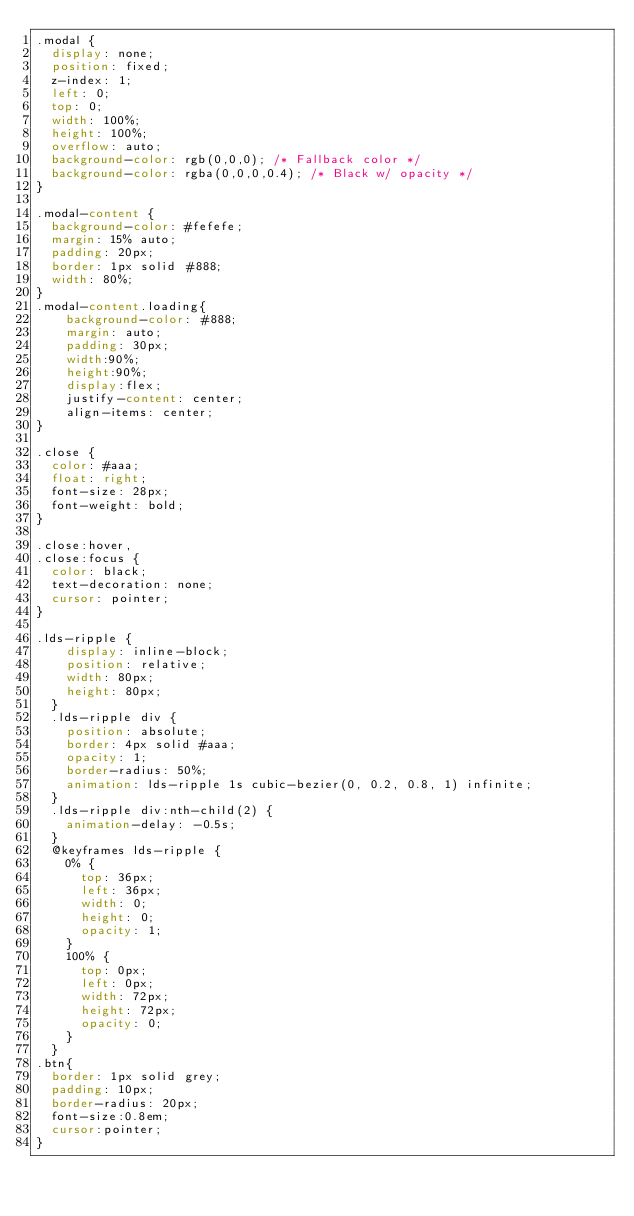<code> <loc_0><loc_0><loc_500><loc_500><_CSS_>.modal {
  display: none;
  position: fixed;
  z-index: 1;
  left: 0;
  top: 0;
  width: 100%; 
  height: 100%;
  overflow: auto;
  background-color: rgb(0,0,0); /* Fallback color */
  background-color: rgba(0,0,0,0.4); /* Black w/ opacity */
}

.modal-content {
  background-color: #fefefe;
  margin: 15% auto;
  padding: 20px;
  border: 1px solid #888;
  width: 80%;
}
.modal-content.loading{
    background-color: #888;
    margin: auto;
    padding: 30px;
    width:90%;
    height:90%;
    display:flex;
    justify-content: center;
    align-items: center;
}

.close {
  color: #aaa;
  float: right;
  font-size: 28px;
  font-weight: bold;
}

.close:hover,
.close:focus {
  color: black;
  text-decoration: none;
  cursor: pointer;
}

.lds-ripple {
    display: inline-block;
    position: relative;
    width: 80px;
    height: 80px;
  }
  .lds-ripple div {
    position: absolute;
    border: 4px solid #aaa;
    opacity: 1;
    border-radius: 50%;
    animation: lds-ripple 1s cubic-bezier(0, 0.2, 0.8, 1) infinite;
  }
  .lds-ripple div:nth-child(2) {
    animation-delay: -0.5s;
  }
  @keyframes lds-ripple {
    0% {
      top: 36px;
      left: 36px;
      width: 0;
      height: 0;
      opacity: 1;
    }
    100% {
      top: 0px;
      left: 0px;
      width: 72px;
      height: 72px;
      opacity: 0;
    }
  }
.btn{
  border: 1px solid grey;
  padding: 10px;
  border-radius: 20px;
  font-size:0.8em;
  cursor:pointer;
}</code> 